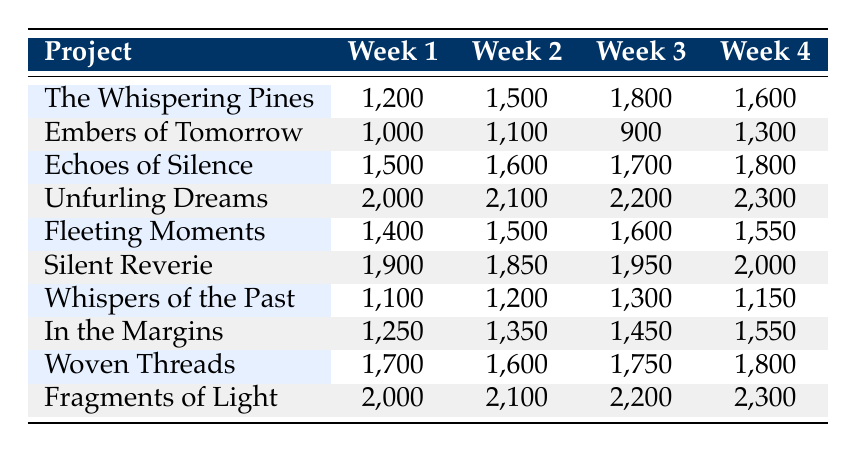What is the highest word count recorded for "Silent Reverie"? The table shows the word counts for "Silent Reverie" across four weeks. The values are 1900, 1850, 1950, and 2000. The highest among these is 2000.
Answer: 2000 Which project had the most consistent weekly word count? To determine consistency, compare the differences between weekly word counts for each project. "Woven Threads" fluctuated from 1700 to 1800, with only minor variations, while others show more variance. Thus, "Woven Threads" is the most consistent.
Answer: Woven Threads What is the total word count for "Unfurling Dreams"? The table shows the weekly word counts for "Unfurling Dreams": 2000, 2100, 2200, and 2300. Add these together: 2000 + 2100 + 2200 + 2300 = 8600.
Answer: 8600 Did "Embers of Tomorrow" ever exceed 1300 words in a single week? In the table, the word counts for "Embers of Tomorrow" are 1000, 1100, 900, and 1300. The highest count is 1300, so it did not exceed this number.
Answer: No What is the average weekly word count for "In the Margins"? The weekly counts are 1250, 1350, 1450, and 1550. To find the average, sum these counts (1250 + 1350 + 1450 + 1550 = 5600) and divide by the number of weeks (4): 5600 / 4 = 1400.
Answer: 1400 Which project achieved the highest word count in the final week? The final week listed in the table shows "Fragments of Light" with 2300 words, which is higher than any other project listed for that week.
Answer: Fragments of Light How many projects had a word count below 1200 in any week? Review the table for each project. "Whispers of the Past" had a count of 1100 in the first week, and "Embers of Tomorrow" had a count of 900. Thus, there are two projects that had a weekly count below 1200.
Answer: 2 What was the overall trend for "Fleeting Moments"? Observing the weekly counts, "Fleeting Moments" had counts of 1400, 1500, 1600, and 1550. The majority of counts increased or saw minor fluctuations, indicating a generally positive trend.
Answer: Positive trend What was the difference in word count between the first and last week of "Echoes of Silence"? The first week's count for "Echoes of Silence" was 1500, and the last week's count was 1800. The difference is 1800 - 1500 = 300.
Answer: 300 